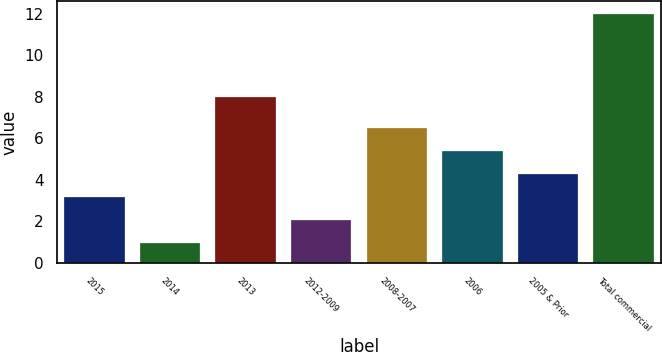<chart> <loc_0><loc_0><loc_500><loc_500><bar_chart><fcel>2015<fcel>2014<fcel>2013<fcel>2012-2009<fcel>2008-2007<fcel>2006<fcel>2005 & Prior<fcel>Total commercial<nl><fcel>3.17<fcel>0.95<fcel>8<fcel>2.06<fcel>6.5<fcel>5.39<fcel>4.28<fcel>12<nl></chart> 